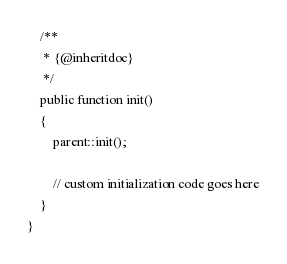Convert code to text. <code><loc_0><loc_0><loc_500><loc_500><_PHP_>    /**
     * {@inheritdoc}
     */
    public function init()
    {
        parent::init();

        // custom initialization code goes here
    }
}
</code> 